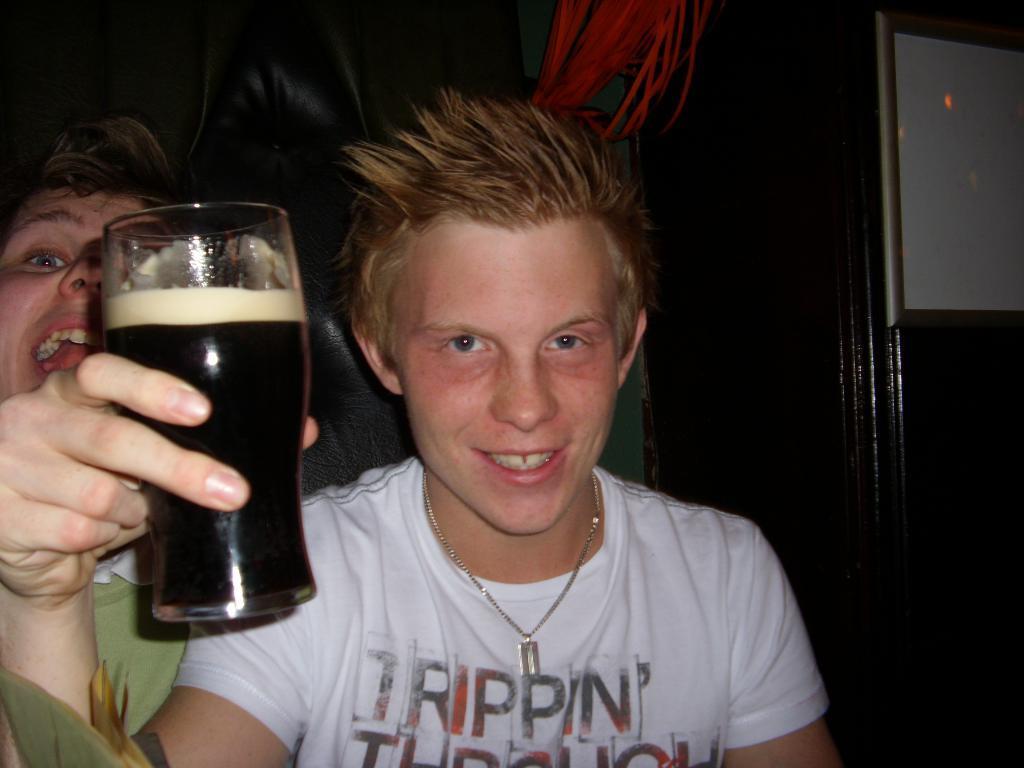Please provide a concise description of this image. In this image we can see a man wearing white t shirt and smiling and holding the glass of drink. We can also see another man. In the background we can see the white board attached to the wooden object. 